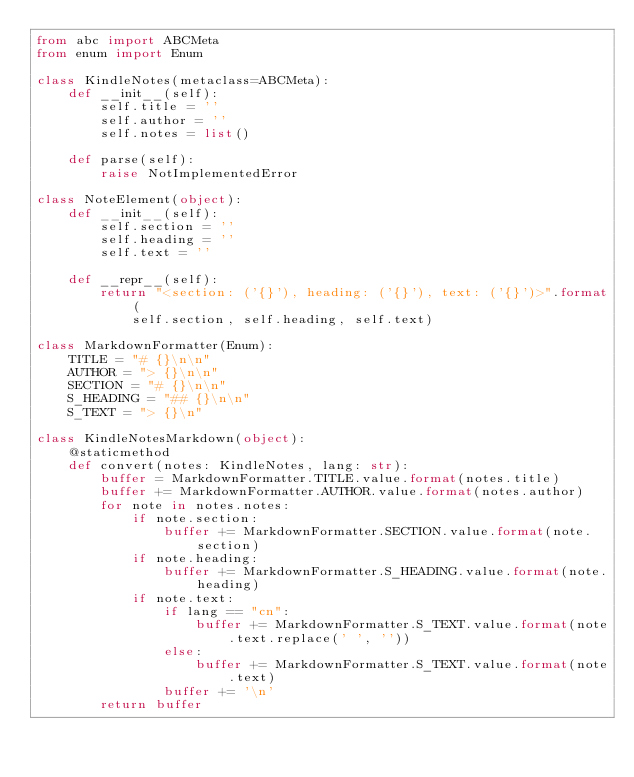<code> <loc_0><loc_0><loc_500><loc_500><_Python_>from abc import ABCMeta
from enum import Enum

class KindleNotes(metaclass=ABCMeta):
    def __init__(self):
        self.title = ''
        self.author = ''
        self.notes = list()

    def parse(self):
        raise NotImplementedError

class NoteElement(object):
    def __init__(self):
        self.section = ''
        self.heading = ''
        self.text = ''

    def __repr__(self):
        return "<section: ('{}'), heading: ('{}'), text: ('{}')>".format(
            self.section, self.heading, self.text)

class MarkdownFormatter(Enum):
    TITLE = "# {}\n\n"
    AUTHOR = "> {}\n\n"
    SECTION = "# {}\n\n"
    S_HEADING = "## {}\n\n"
    S_TEXT = "> {}\n"

class KindleNotesMarkdown(object):
    @staticmethod
    def convert(notes: KindleNotes, lang: str):
        buffer = MarkdownFormatter.TITLE.value.format(notes.title)
        buffer += MarkdownFormatter.AUTHOR.value.format(notes.author)
        for note in notes.notes:
            if note.section:
                buffer += MarkdownFormatter.SECTION.value.format(note.section)
            if note.heading:
                buffer += MarkdownFormatter.S_HEADING.value.format(note.heading)
            if note.text:
                if lang == "cn":
                    buffer += MarkdownFormatter.S_TEXT.value.format(note.text.replace(' ', ''))
                else:
                    buffer += MarkdownFormatter.S_TEXT.value.format(note.text)
                buffer += '\n'
        return buffer
</code> 